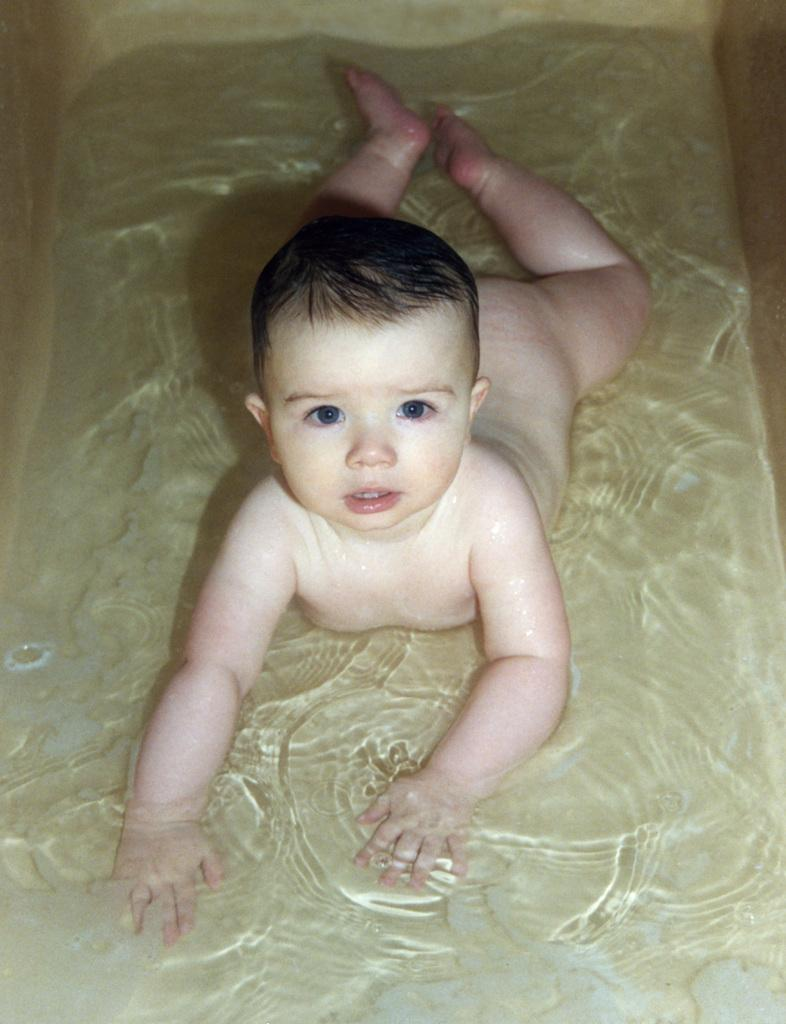What is the main subject of the image? There is a baby in the image. Where is the baby located in the image? The baby is lying in the water. What level of water is the baby submerged in the image? The provided facts do not specify the level of water the baby is submerged in, so it cannot be determined from the image. 